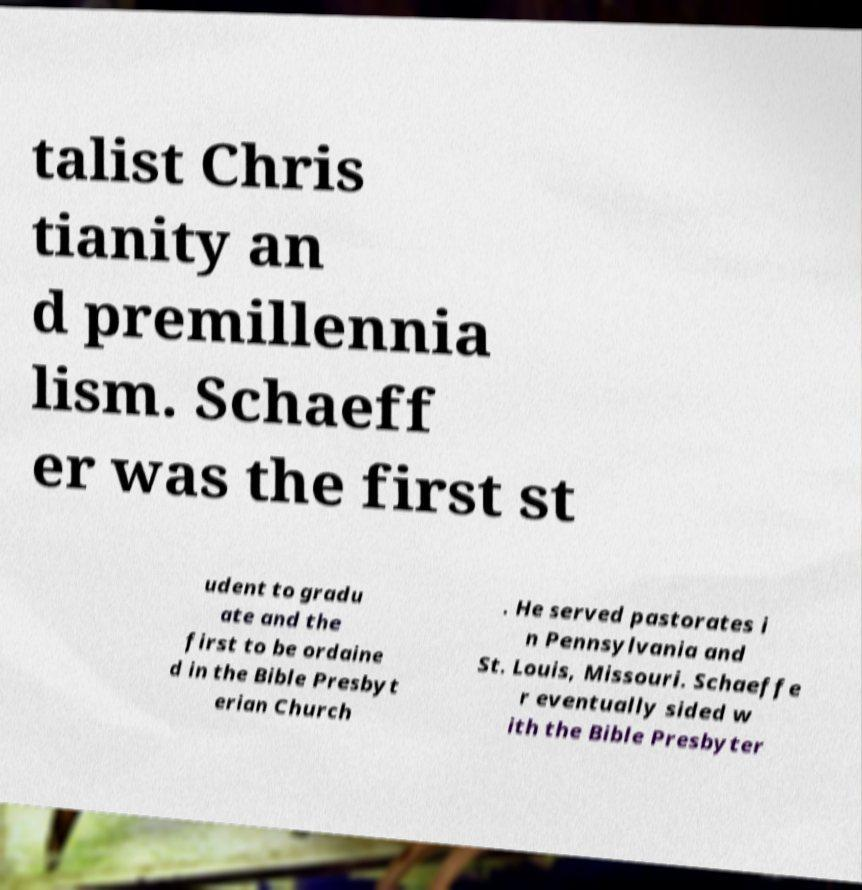Can you read and provide the text displayed in the image?This photo seems to have some interesting text. Can you extract and type it out for me? talist Chris tianity an d premillennia lism. Schaeff er was the first st udent to gradu ate and the first to be ordaine d in the Bible Presbyt erian Church . He served pastorates i n Pennsylvania and St. Louis, Missouri. Schaeffe r eventually sided w ith the Bible Presbyter 